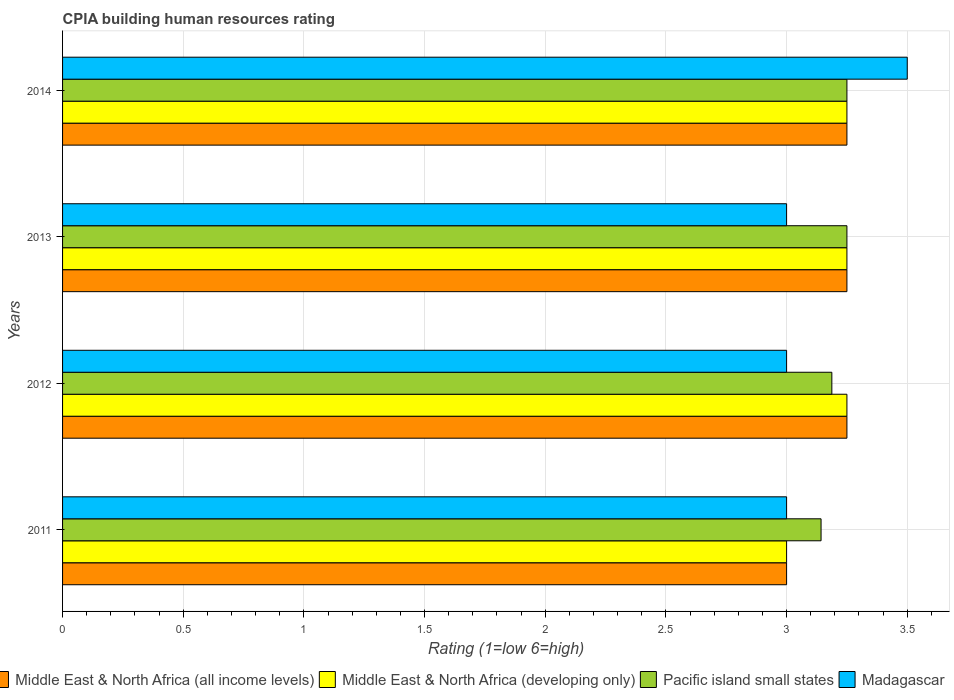How many different coloured bars are there?
Offer a very short reply. 4. How many groups of bars are there?
Your answer should be compact. 4. What is the label of the 1st group of bars from the top?
Give a very brief answer. 2014. In how many cases, is the number of bars for a given year not equal to the number of legend labels?
Your answer should be compact. 0. What is the CPIA rating in Middle East & North Africa (developing only) in 2012?
Your answer should be very brief. 3.25. Across all years, what is the maximum CPIA rating in Madagascar?
Make the answer very short. 3.5. Across all years, what is the minimum CPIA rating in Madagascar?
Provide a succinct answer. 3. In which year was the CPIA rating in Madagascar minimum?
Make the answer very short. 2011. What is the difference between the CPIA rating in Madagascar in 2012 and that in 2013?
Keep it short and to the point. 0. What is the difference between the CPIA rating in Pacific island small states in 2013 and the CPIA rating in Madagascar in 2012?
Provide a succinct answer. 0.25. What is the average CPIA rating in Middle East & North Africa (all income levels) per year?
Offer a very short reply. 3.19. In the year 2014, what is the difference between the CPIA rating in Pacific island small states and CPIA rating in Middle East & North Africa (developing only)?
Your response must be concise. 0. In how many years, is the CPIA rating in Pacific island small states greater than 2.8 ?
Provide a succinct answer. 4. What is the ratio of the CPIA rating in Middle East & North Africa (developing only) in 2011 to that in 2013?
Ensure brevity in your answer.  0.92. What is the difference between the highest and the second highest CPIA rating in Pacific island small states?
Keep it short and to the point. 0. What is the difference between the highest and the lowest CPIA rating in Pacific island small states?
Your answer should be very brief. 0.11. Is it the case that in every year, the sum of the CPIA rating in Pacific island small states and CPIA rating in Madagascar is greater than the sum of CPIA rating in Middle East & North Africa (all income levels) and CPIA rating in Middle East & North Africa (developing only)?
Provide a succinct answer. No. What does the 1st bar from the top in 2012 represents?
Your response must be concise. Madagascar. What does the 1st bar from the bottom in 2013 represents?
Keep it short and to the point. Middle East & North Africa (all income levels). Is it the case that in every year, the sum of the CPIA rating in Middle East & North Africa (developing only) and CPIA rating in Middle East & North Africa (all income levels) is greater than the CPIA rating in Madagascar?
Make the answer very short. Yes. How many bars are there?
Your answer should be very brief. 16. Are all the bars in the graph horizontal?
Offer a very short reply. Yes. What is the difference between two consecutive major ticks on the X-axis?
Keep it short and to the point. 0.5. Are the values on the major ticks of X-axis written in scientific E-notation?
Ensure brevity in your answer.  No. Does the graph contain any zero values?
Your answer should be compact. No. What is the title of the graph?
Provide a short and direct response. CPIA building human resources rating. What is the label or title of the X-axis?
Provide a succinct answer. Rating (1=low 6=high). What is the label or title of the Y-axis?
Your response must be concise. Years. What is the Rating (1=low 6=high) of Middle East & North Africa (all income levels) in 2011?
Keep it short and to the point. 3. What is the Rating (1=low 6=high) of Pacific island small states in 2011?
Your response must be concise. 3.14. What is the Rating (1=low 6=high) in Middle East & North Africa (all income levels) in 2012?
Your answer should be compact. 3.25. What is the Rating (1=low 6=high) in Pacific island small states in 2012?
Provide a short and direct response. 3.19. What is the Rating (1=low 6=high) in Middle East & North Africa (all income levels) in 2013?
Offer a very short reply. 3.25. What is the Rating (1=low 6=high) in Middle East & North Africa (developing only) in 2013?
Provide a short and direct response. 3.25. What is the Rating (1=low 6=high) in Pacific island small states in 2013?
Provide a succinct answer. 3.25. What is the Rating (1=low 6=high) in Pacific island small states in 2014?
Offer a very short reply. 3.25. What is the Rating (1=low 6=high) in Madagascar in 2014?
Your answer should be very brief. 3.5. Across all years, what is the maximum Rating (1=low 6=high) of Middle East & North Africa (developing only)?
Make the answer very short. 3.25. Across all years, what is the maximum Rating (1=low 6=high) in Pacific island small states?
Ensure brevity in your answer.  3.25. Across all years, what is the maximum Rating (1=low 6=high) in Madagascar?
Make the answer very short. 3.5. Across all years, what is the minimum Rating (1=low 6=high) in Middle East & North Africa (all income levels)?
Your answer should be compact. 3. Across all years, what is the minimum Rating (1=low 6=high) of Pacific island small states?
Make the answer very short. 3.14. Across all years, what is the minimum Rating (1=low 6=high) of Madagascar?
Provide a succinct answer. 3. What is the total Rating (1=low 6=high) of Middle East & North Africa (all income levels) in the graph?
Provide a short and direct response. 12.75. What is the total Rating (1=low 6=high) of Middle East & North Africa (developing only) in the graph?
Keep it short and to the point. 12.75. What is the total Rating (1=low 6=high) of Pacific island small states in the graph?
Give a very brief answer. 12.83. What is the total Rating (1=low 6=high) in Madagascar in the graph?
Provide a short and direct response. 12.5. What is the difference between the Rating (1=low 6=high) in Middle East & North Africa (developing only) in 2011 and that in 2012?
Your response must be concise. -0.25. What is the difference between the Rating (1=low 6=high) in Pacific island small states in 2011 and that in 2012?
Offer a very short reply. -0.04. What is the difference between the Rating (1=low 6=high) of Middle East & North Africa (all income levels) in 2011 and that in 2013?
Ensure brevity in your answer.  -0.25. What is the difference between the Rating (1=low 6=high) in Middle East & North Africa (developing only) in 2011 and that in 2013?
Your answer should be compact. -0.25. What is the difference between the Rating (1=low 6=high) in Pacific island small states in 2011 and that in 2013?
Ensure brevity in your answer.  -0.11. What is the difference between the Rating (1=low 6=high) in Madagascar in 2011 and that in 2013?
Ensure brevity in your answer.  0. What is the difference between the Rating (1=low 6=high) in Pacific island small states in 2011 and that in 2014?
Your response must be concise. -0.11. What is the difference between the Rating (1=low 6=high) in Pacific island small states in 2012 and that in 2013?
Your answer should be very brief. -0.06. What is the difference between the Rating (1=low 6=high) of Middle East & North Africa (developing only) in 2012 and that in 2014?
Provide a succinct answer. 0. What is the difference between the Rating (1=low 6=high) in Pacific island small states in 2012 and that in 2014?
Offer a terse response. -0.06. What is the difference between the Rating (1=low 6=high) of Middle East & North Africa (developing only) in 2013 and that in 2014?
Your answer should be compact. 0. What is the difference between the Rating (1=low 6=high) of Pacific island small states in 2013 and that in 2014?
Offer a terse response. 0. What is the difference between the Rating (1=low 6=high) in Middle East & North Africa (all income levels) in 2011 and the Rating (1=low 6=high) in Middle East & North Africa (developing only) in 2012?
Ensure brevity in your answer.  -0.25. What is the difference between the Rating (1=low 6=high) in Middle East & North Africa (all income levels) in 2011 and the Rating (1=low 6=high) in Pacific island small states in 2012?
Give a very brief answer. -0.19. What is the difference between the Rating (1=low 6=high) in Middle East & North Africa (developing only) in 2011 and the Rating (1=low 6=high) in Pacific island small states in 2012?
Your response must be concise. -0.19. What is the difference between the Rating (1=low 6=high) in Pacific island small states in 2011 and the Rating (1=low 6=high) in Madagascar in 2012?
Your answer should be compact. 0.14. What is the difference between the Rating (1=low 6=high) in Middle East & North Africa (all income levels) in 2011 and the Rating (1=low 6=high) in Middle East & North Africa (developing only) in 2013?
Provide a short and direct response. -0.25. What is the difference between the Rating (1=low 6=high) in Pacific island small states in 2011 and the Rating (1=low 6=high) in Madagascar in 2013?
Your answer should be compact. 0.14. What is the difference between the Rating (1=low 6=high) in Middle East & North Africa (all income levels) in 2011 and the Rating (1=low 6=high) in Madagascar in 2014?
Offer a terse response. -0.5. What is the difference between the Rating (1=low 6=high) of Middle East & North Africa (developing only) in 2011 and the Rating (1=low 6=high) of Pacific island small states in 2014?
Make the answer very short. -0.25. What is the difference between the Rating (1=low 6=high) in Middle East & North Africa (developing only) in 2011 and the Rating (1=low 6=high) in Madagascar in 2014?
Your answer should be very brief. -0.5. What is the difference between the Rating (1=low 6=high) of Pacific island small states in 2011 and the Rating (1=low 6=high) of Madagascar in 2014?
Your answer should be compact. -0.36. What is the difference between the Rating (1=low 6=high) of Middle East & North Africa (all income levels) in 2012 and the Rating (1=low 6=high) of Madagascar in 2013?
Make the answer very short. 0.25. What is the difference between the Rating (1=low 6=high) in Middle East & North Africa (developing only) in 2012 and the Rating (1=low 6=high) in Pacific island small states in 2013?
Ensure brevity in your answer.  0. What is the difference between the Rating (1=low 6=high) in Pacific island small states in 2012 and the Rating (1=low 6=high) in Madagascar in 2013?
Make the answer very short. 0.19. What is the difference between the Rating (1=low 6=high) of Middle East & North Africa (all income levels) in 2012 and the Rating (1=low 6=high) of Middle East & North Africa (developing only) in 2014?
Your answer should be very brief. 0. What is the difference between the Rating (1=low 6=high) in Middle East & North Africa (all income levels) in 2012 and the Rating (1=low 6=high) in Pacific island small states in 2014?
Give a very brief answer. 0. What is the difference between the Rating (1=low 6=high) in Pacific island small states in 2012 and the Rating (1=low 6=high) in Madagascar in 2014?
Provide a short and direct response. -0.31. What is the difference between the Rating (1=low 6=high) in Middle East & North Africa (all income levels) in 2013 and the Rating (1=low 6=high) in Middle East & North Africa (developing only) in 2014?
Your answer should be very brief. 0. What is the difference between the Rating (1=low 6=high) in Middle East & North Africa (developing only) in 2013 and the Rating (1=low 6=high) in Madagascar in 2014?
Keep it short and to the point. -0.25. What is the difference between the Rating (1=low 6=high) of Pacific island small states in 2013 and the Rating (1=low 6=high) of Madagascar in 2014?
Offer a terse response. -0.25. What is the average Rating (1=low 6=high) of Middle East & North Africa (all income levels) per year?
Your answer should be compact. 3.19. What is the average Rating (1=low 6=high) of Middle East & North Africa (developing only) per year?
Your answer should be compact. 3.19. What is the average Rating (1=low 6=high) in Pacific island small states per year?
Your response must be concise. 3.21. What is the average Rating (1=low 6=high) of Madagascar per year?
Give a very brief answer. 3.12. In the year 2011, what is the difference between the Rating (1=low 6=high) in Middle East & North Africa (all income levels) and Rating (1=low 6=high) in Pacific island small states?
Give a very brief answer. -0.14. In the year 2011, what is the difference between the Rating (1=low 6=high) in Middle East & North Africa (all income levels) and Rating (1=low 6=high) in Madagascar?
Make the answer very short. 0. In the year 2011, what is the difference between the Rating (1=low 6=high) of Middle East & North Africa (developing only) and Rating (1=low 6=high) of Pacific island small states?
Your answer should be very brief. -0.14. In the year 2011, what is the difference between the Rating (1=low 6=high) of Pacific island small states and Rating (1=low 6=high) of Madagascar?
Offer a terse response. 0.14. In the year 2012, what is the difference between the Rating (1=low 6=high) in Middle East & North Africa (all income levels) and Rating (1=low 6=high) in Pacific island small states?
Your answer should be compact. 0.06. In the year 2012, what is the difference between the Rating (1=low 6=high) of Middle East & North Africa (all income levels) and Rating (1=low 6=high) of Madagascar?
Offer a very short reply. 0.25. In the year 2012, what is the difference between the Rating (1=low 6=high) of Middle East & North Africa (developing only) and Rating (1=low 6=high) of Pacific island small states?
Your answer should be very brief. 0.06. In the year 2012, what is the difference between the Rating (1=low 6=high) of Middle East & North Africa (developing only) and Rating (1=low 6=high) of Madagascar?
Make the answer very short. 0.25. In the year 2012, what is the difference between the Rating (1=low 6=high) in Pacific island small states and Rating (1=low 6=high) in Madagascar?
Your answer should be very brief. 0.19. In the year 2013, what is the difference between the Rating (1=low 6=high) of Middle East & North Africa (all income levels) and Rating (1=low 6=high) of Middle East & North Africa (developing only)?
Offer a very short reply. 0. In the year 2013, what is the difference between the Rating (1=low 6=high) of Middle East & North Africa (all income levels) and Rating (1=low 6=high) of Madagascar?
Keep it short and to the point. 0.25. In the year 2013, what is the difference between the Rating (1=low 6=high) of Middle East & North Africa (developing only) and Rating (1=low 6=high) of Pacific island small states?
Offer a terse response. 0. In the year 2013, what is the difference between the Rating (1=low 6=high) in Pacific island small states and Rating (1=low 6=high) in Madagascar?
Your answer should be compact. 0.25. In the year 2014, what is the difference between the Rating (1=low 6=high) of Middle East & North Africa (all income levels) and Rating (1=low 6=high) of Pacific island small states?
Your answer should be very brief. 0. In the year 2014, what is the difference between the Rating (1=low 6=high) of Middle East & North Africa (all income levels) and Rating (1=low 6=high) of Madagascar?
Offer a terse response. -0.25. In the year 2014, what is the difference between the Rating (1=low 6=high) in Middle East & North Africa (developing only) and Rating (1=low 6=high) in Pacific island small states?
Keep it short and to the point. 0. In the year 2014, what is the difference between the Rating (1=low 6=high) of Pacific island small states and Rating (1=low 6=high) of Madagascar?
Your answer should be very brief. -0.25. What is the ratio of the Rating (1=low 6=high) of Pacific island small states in 2011 to that in 2012?
Provide a short and direct response. 0.99. What is the ratio of the Rating (1=low 6=high) of Madagascar in 2011 to that in 2012?
Keep it short and to the point. 1. What is the ratio of the Rating (1=low 6=high) in Middle East & North Africa (all income levels) in 2011 to that in 2013?
Provide a succinct answer. 0.92. What is the ratio of the Rating (1=low 6=high) in Middle East & North Africa (all income levels) in 2011 to that in 2014?
Ensure brevity in your answer.  0.92. What is the ratio of the Rating (1=low 6=high) in Middle East & North Africa (all income levels) in 2012 to that in 2013?
Provide a succinct answer. 1. What is the ratio of the Rating (1=low 6=high) in Middle East & North Africa (developing only) in 2012 to that in 2013?
Provide a short and direct response. 1. What is the ratio of the Rating (1=low 6=high) of Pacific island small states in 2012 to that in 2013?
Keep it short and to the point. 0.98. What is the ratio of the Rating (1=low 6=high) of Middle East & North Africa (all income levels) in 2012 to that in 2014?
Give a very brief answer. 1. What is the ratio of the Rating (1=low 6=high) of Middle East & North Africa (developing only) in 2012 to that in 2014?
Keep it short and to the point. 1. What is the ratio of the Rating (1=low 6=high) in Pacific island small states in 2012 to that in 2014?
Give a very brief answer. 0.98. What is the ratio of the Rating (1=low 6=high) in Madagascar in 2012 to that in 2014?
Offer a terse response. 0.86. What is the ratio of the Rating (1=low 6=high) in Pacific island small states in 2013 to that in 2014?
Your answer should be very brief. 1. What is the difference between the highest and the second highest Rating (1=low 6=high) of Middle East & North Africa (developing only)?
Make the answer very short. 0. What is the difference between the highest and the second highest Rating (1=low 6=high) of Pacific island small states?
Ensure brevity in your answer.  0. What is the difference between the highest and the second highest Rating (1=low 6=high) in Madagascar?
Provide a succinct answer. 0.5. What is the difference between the highest and the lowest Rating (1=low 6=high) in Pacific island small states?
Make the answer very short. 0.11. 